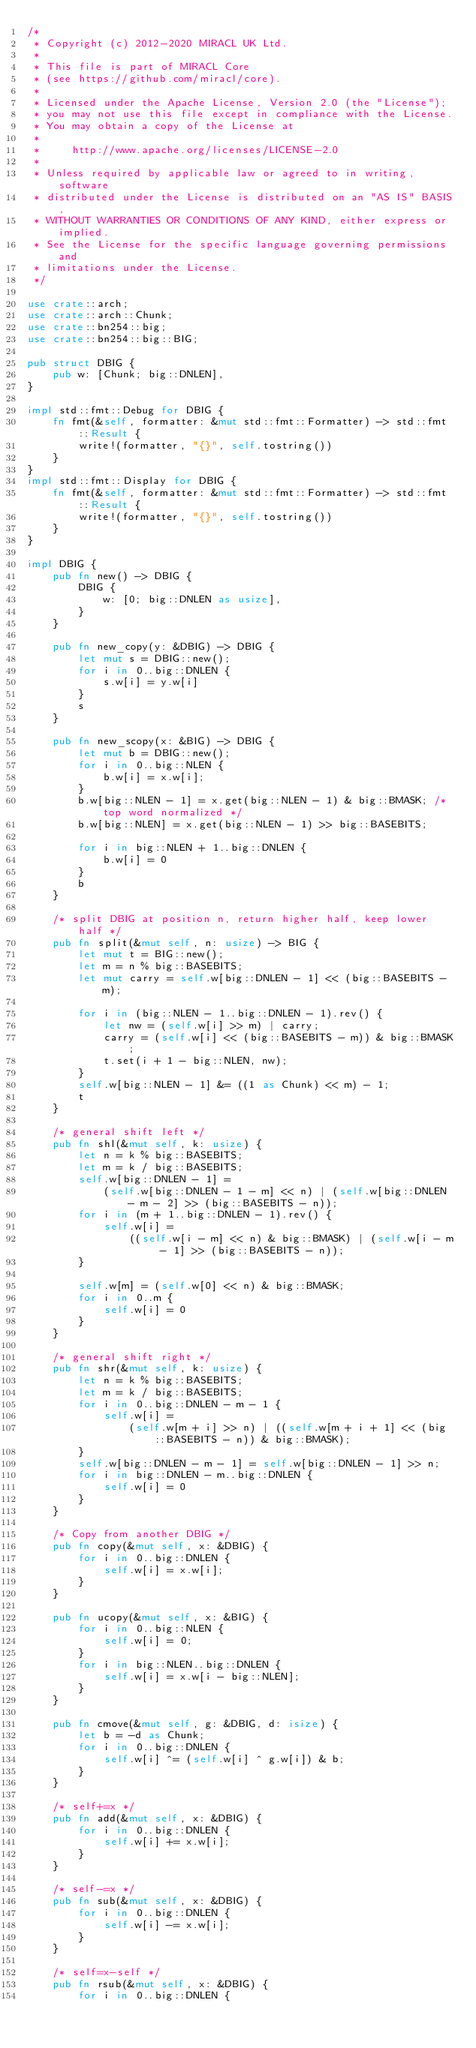Convert code to text. <code><loc_0><loc_0><loc_500><loc_500><_Rust_>/*
 * Copyright (c) 2012-2020 MIRACL UK Ltd.
 *
 * This file is part of MIRACL Core
 * (see https://github.com/miracl/core).
 *
 * Licensed under the Apache License, Version 2.0 (the "License");
 * you may not use this file except in compliance with the License.
 * You may obtain a copy of the License at
 *
 *     http://www.apache.org/licenses/LICENSE-2.0
 *
 * Unless required by applicable law or agreed to in writing, software
 * distributed under the License is distributed on an "AS IS" BASIS,
 * WITHOUT WARRANTIES OR CONDITIONS OF ANY KIND, either express or implied.
 * See the License for the specific language governing permissions and
 * limitations under the License.
 */

use crate::arch;
use crate::arch::Chunk;
use crate::bn254::big;
use crate::bn254::big::BIG;

pub struct DBIG {
    pub w: [Chunk; big::DNLEN],
}

impl std::fmt::Debug for DBIG {
    fn fmt(&self, formatter: &mut std::fmt::Formatter) -> std::fmt::Result {
        write!(formatter, "{}", self.tostring())
    }
}    
impl std::fmt::Display for DBIG {
    fn fmt(&self, formatter: &mut std::fmt::Formatter) -> std::fmt::Result {
        write!(formatter, "{}", self.tostring())
    }
}

impl DBIG {
    pub fn new() -> DBIG {
        DBIG {
            w: [0; big::DNLEN as usize],
        }
    }

    pub fn new_copy(y: &DBIG) -> DBIG {
        let mut s = DBIG::new();
        for i in 0..big::DNLEN {
            s.w[i] = y.w[i]
        }
        s
    }

    pub fn new_scopy(x: &BIG) -> DBIG {
        let mut b = DBIG::new();
        for i in 0..big::NLEN {
            b.w[i] = x.w[i];
        }
        b.w[big::NLEN - 1] = x.get(big::NLEN - 1) & big::BMASK; /* top word normalized */
        b.w[big::NLEN] = x.get(big::NLEN - 1) >> big::BASEBITS;

        for i in big::NLEN + 1..big::DNLEN {
            b.w[i] = 0
        }
        b
    }

    /* split DBIG at position n, return higher half, keep lower half */
    pub fn split(&mut self, n: usize) -> BIG {
        let mut t = BIG::new();
        let m = n % big::BASEBITS;
        let mut carry = self.w[big::DNLEN - 1] << (big::BASEBITS - m);

        for i in (big::NLEN - 1..big::DNLEN - 1).rev() {
            let nw = (self.w[i] >> m) | carry;
            carry = (self.w[i] << (big::BASEBITS - m)) & big::BMASK;
            t.set(i + 1 - big::NLEN, nw);
        }
        self.w[big::NLEN - 1] &= ((1 as Chunk) << m) - 1;
        t
    }

    /* general shift left */
    pub fn shl(&mut self, k: usize) {
        let n = k % big::BASEBITS;
        let m = k / big::BASEBITS;
        self.w[big::DNLEN - 1] =
            (self.w[big::DNLEN - 1 - m] << n) | (self.w[big::DNLEN - m - 2] >> (big::BASEBITS - n));
        for i in (m + 1..big::DNLEN - 1).rev() {
            self.w[i] =
                ((self.w[i - m] << n) & big::BMASK) | (self.w[i - m - 1] >> (big::BASEBITS - n));
        }

        self.w[m] = (self.w[0] << n) & big::BMASK;
        for i in 0..m {
            self.w[i] = 0
        }
    }

    /* general shift right */
    pub fn shr(&mut self, k: usize) {
        let n = k % big::BASEBITS;
        let m = k / big::BASEBITS;
        for i in 0..big::DNLEN - m - 1 {
            self.w[i] =
                (self.w[m + i] >> n) | ((self.w[m + i + 1] << (big::BASEBITS - n)) & big::BMASK);
        }
        self.w[big::DNLEN - m - 1] = self.w[big::DNLEN - 1] >> n;
        for i in big::DNLEN - m..big::DNLEN {
            self.w[i] = 0
        }
    }

    /* Copy from another DBIG */
    pub fn copy(&mut self, x: &DBIG) {
        for i in 0..big::DNLEN {
            self.w[i] = x.w[i];
        }
    }

    pub fn ucopy(&mut self, x: &BIG) {
        for i in 0..big::NLEN {
            self.w[i] = 0;
        }
        for i in big::NLEN..big::DNLEN {
            self.w[i] = x.w[i - big::NLEN];
        }
    }

    pub fn cmove(&mut self, g: &DBIG, d: isize) {
        let b = -d as Chunk;
        for i in 0..big::DNLEN {
            self.w[i] ^= (self.w[i] ^ g.w[i]) & b;
        }
    }

    /* self+=x */
    pub fn add(&mut self, x: &DBIG) {
        for i in 0..big::DNLEN {
            self.w[i] += x.w[i];
        }
    }

    /* self-=x */
    pub fn sub(&mut self, x: &DBIG) {
        for i in 0..big::DNLEN {
            self.w[i] -= x.w[i];
        }
    }

    /* self=x-self */
    pub fn rsub(&mut self, x: &DBIG) {
        for i in 0..big::DNLEN {</code> 